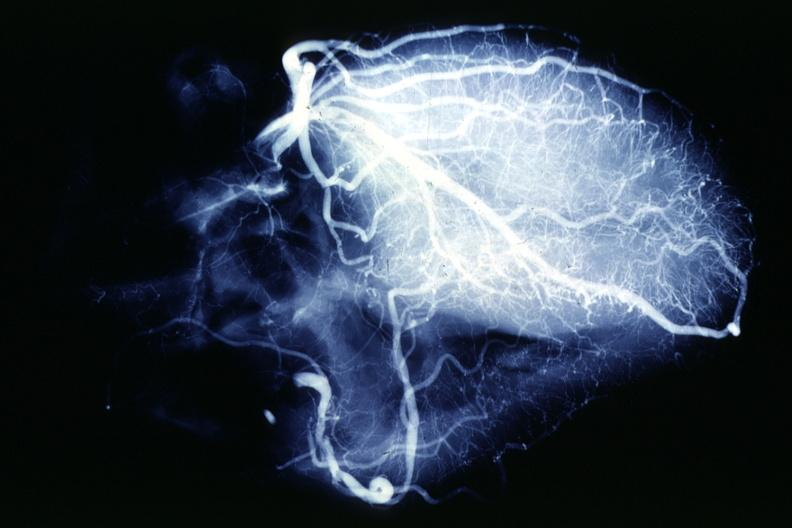does leiomyosarcoma show x-ray postmortcoronary angiogram rather typical example of proximal lesions?
Answer the question using a single word or phrase. No 